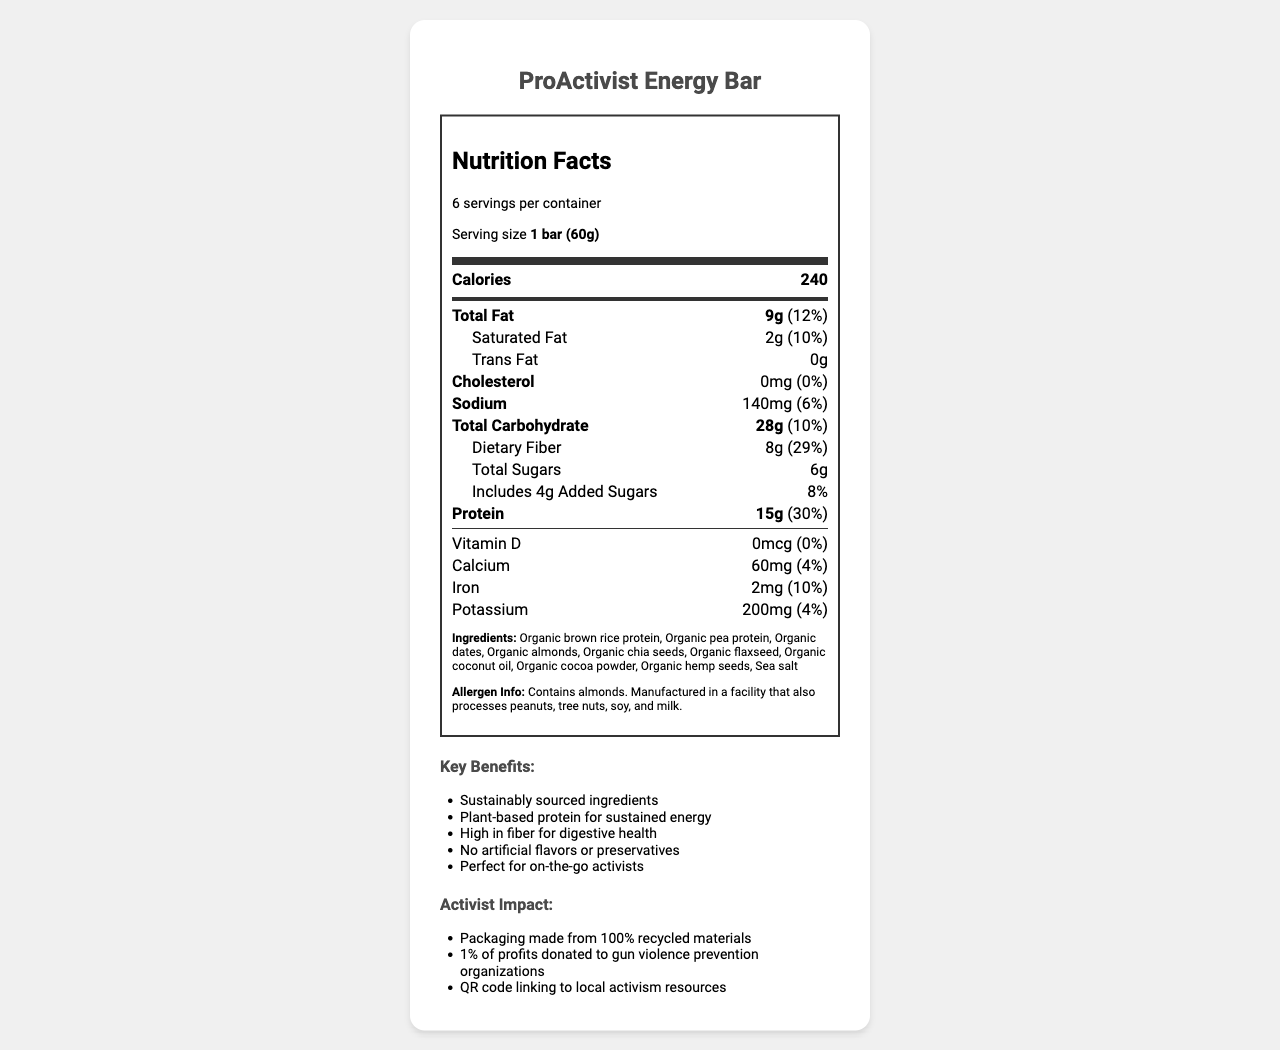what is the serving size of the ProActivist Energy Bar? The serving size is mentioned at the top of the Nutrition Facts label as "Serving size 1 bar (60g)".
Answer: 1 bar (60g) How many grams of total carbohydrates are there in one serving? Under the "Total Carbohydrate" section, it is specified that there are 28g of total carbohydrates per serving.
Answer: 28g What percentage of the daily value of protein does one bar provide? The protein section states that one bar provides 15g of protein, which is 30% of the daily value.
Answer: 30% How much dietary fiber does one bar contain? The dietary fiber is listed as 8g under the Total Carbohydrate section.
Answer: 8g What is the amount of potassium in one serving? The potassium content is listed as 200mg with a daily value of 4%.
Answer: 200mg Which ingredient is listed first in the ingredients section? The ingredients are listed in order of quantity, and the first ingredient listed is Organic brown rice protein.
Answer: Organic brown rice protein Does the ProActivist Energy Bar contain any cholesterol? The section for cholesterol shows "0mg" and "0%" for the daily value, indicating there is no cholesterol in the bar.
Answer: No Which of the following is a key marketing claim of the ProActivist Energy Bar? A. Contains artificial flavors B. High in fiber for digestive health C. Low sodium According to the marketing claims section, "High in fiber for digestive health" is one of the claims.
Answer: B What is the allergen information provided for this product? The allergen information is detailed under the ingredients section.
Answer: Contains almonds. Manufactured in a facility that also processes peanuts, tree nuts, soy, and milk. What environmental initiative does the packaging boast? A. Biodegradable packaging B. Packaging made from 100% recycled materials C. Compostable packaging D. No packaging In the activist benefits section, it states that the packaging is made from 100% recycled materials.
Answer: B Is there any added sugars in the bar? The label mentions that there are 4g of added sugars with a daily value percentage of 8%.
Answer: Yes Which vitamin or mineral has the highest daily value percentage? The percentage daily value for protein is the highest at 30%.
Answer: Protein Summarize the main points of the ProActivist Energy Bar Nutrition Facts Label. The label details nutritional content like calories, protein, fats, and fiber, emphasizes plant-based and sustainably sourced ingredients, and highlights the product's environmental and activist benefits.
Answer: The ProActivist Energy Bar provides 240 calories per serving with 15g of protein (30% DV) and 8g of dietary fiber (29% DV). Key ingredients include organic brown rice protein, organic pea protein, and organic almonds. The product claims sustainably sourced ingredients and no artificial flavors or preservatives. It's beneficial for digestive health and offers plant-based protein for sustained energy. Additionally, the packaging is made from recycled materials, and 1% of profits support gun violence prevention organizations. Allergen information notes the presence of almonds and potential cross-contact with other allergens. How much Vitamin D is in one serving of the ProActivist Energy Bar? The Vitamin D section shows there is 0mcg, with 0% daily value.
Answer: 0mcg Can I determine the exact facility where this product was manufactured? The document only mentions that the product was manufactured in a facility that processes certain allergens, but it does not provide the exact facility details.
Answer: Not enough information 